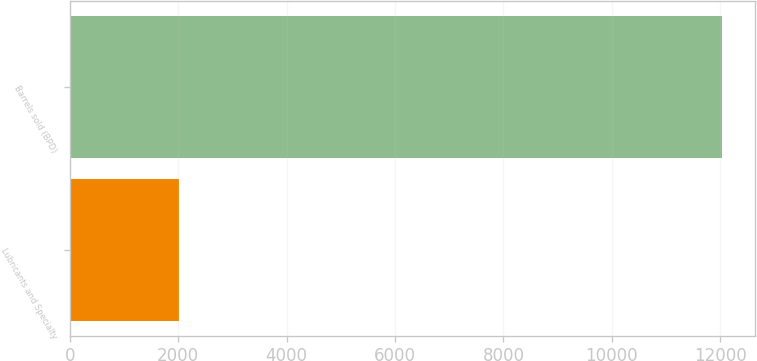Convert chart to OTSL. <chart><loc_0><loc_0><loc_500><loc_500><bar_chart><fcel>Lubricants and Specialty<fcel>Barrels sold (BPD)<nl><fcel>2016<fcel>12030<nl></chart> 